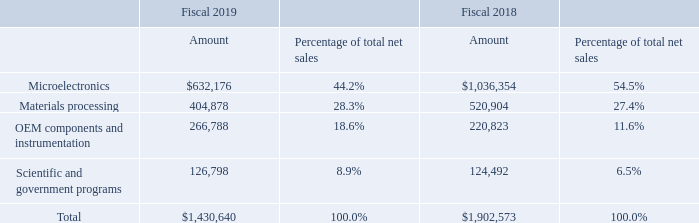Net Sales
Market Application
The following table sets forth, for the periods indicated, the amount of net sales and their relative
percentages of total net sales by market application (dollars in thousands):
During fiscal 2019, net sales decreased by $471.9 million, or 25%, compared to fiscal 2018, with decreases in the microelectronics and materials processing markets, partially offset by increases in the OEM components and instrumentation market. Ondax, which we acquired on October 5, 2018, contributed $6.4 million in incremental net sales to the materials processing market in the ILS segment in fiscal 2019. In fiscal 2019, we continued to experience weaker demand in the microelectronics and materials processing markets. Entering fiscal 2020, we have started seeing indications which could lead to increased future demand in the microelectronics flat panel display market, but this is balanced by possible continuing headwinds in the global materials processing industry.
What is the change in net sales in 2019? Decreased by $471.9 million. What is the amount of Microelectronics in 2019?
Answer scale should be: thousand. $632,176. In which years is net sales calculated? 2019, 2018. In which year was Materials processing a larger percentage of total net sales? 28.3%>27.4%
Answer: 2019. What was the change in the amount of OEM components and instrumentation in 2019 from 2018?
Answer scale should be: thousand. 266,788-220,823
Answer: 45965. What was the percentage change in the amount of OEM components and instrumentation in 2019 from 2018?
Answer scale should be: percent. (266,788-220,823)/220,823
Answer: 20.82. 